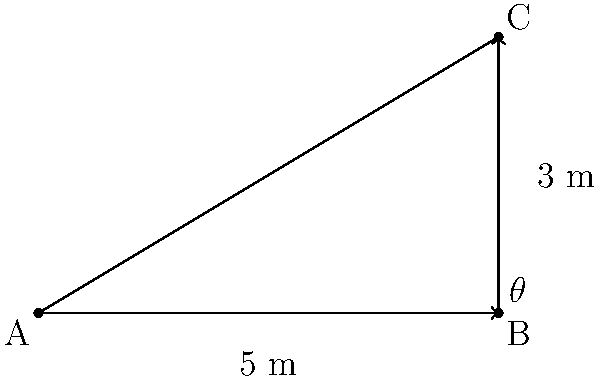In an interactive installation designed to study spatial perception, you've created a sloped walkway. The walkway rises 3 meters over a horizontal distance of 5 meters. What is the angle of inclination (θ) of the walkway? To find the angle of inclination (θ), we can use the inverse tangent function (arctan or tan^(-1)). Here's the step-by-step process:

1. Identify the right triangle formed by the walkway:
   - The base (adjacent side) is 5 meters
   - The height (opposite side) is 3 meters

2. Calculate the ratio of the opposite side to the adjacent side:
   $\frac{\text{opposite}}{\text{adjacent}} = \frac{3}{5} = 0.6$

3. Apply the inverse tangent function to this ratio:
   $\theta = \tan^{-1}(\frac{3}{5}) = \tan^{-1}(0.6)$

4. Calculate the result:
   $\theta \approx 30.96^\circ$

5. Round to the nearest degree:
   $\theta \approx 31^\circ$

This angle represents the slope of the walkway, which is crucial for studying how participants perceive and navigate inclined surfaces in your interactive installation.
Answer: $31^\circ$ 